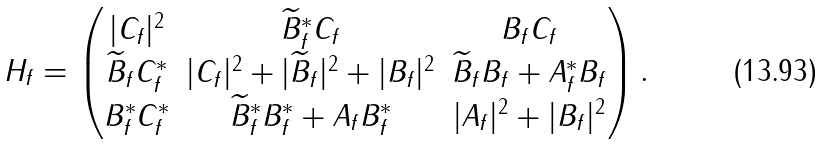<formula> <loc_0><loc_0><loc_500><loc_500>H _ { f } = \begin{pmatrix} | C _ { f } | ^ { 2 } & \widetilde { B } _ { f } ^ { * } C _ { f } & B _ { f } C _ { f } \\ \widetilde { B } _ { f } C _ { f } ^ { * } & | C _ { f } | ^ { 2 } + | \widetilde { B } _ { f } | ^ { 2 } + | B _ { f } | ^ { 2 } & \widetilde { B } _ { f } B _ { f } + A ^ { * } _ { f } B _ { f } \\ B _ { f } ^ { * } C _ { f } ^ { * } & \widetilde { B } _ { f } ^ { * } B ^ { * } _ { f } + A _ { f } B _ { f } ^ { * } & | A _ { f } | ^ { 2 } + | B _ { f } | ^ { 2 } \\ \end{pmatrix} .</formula> 